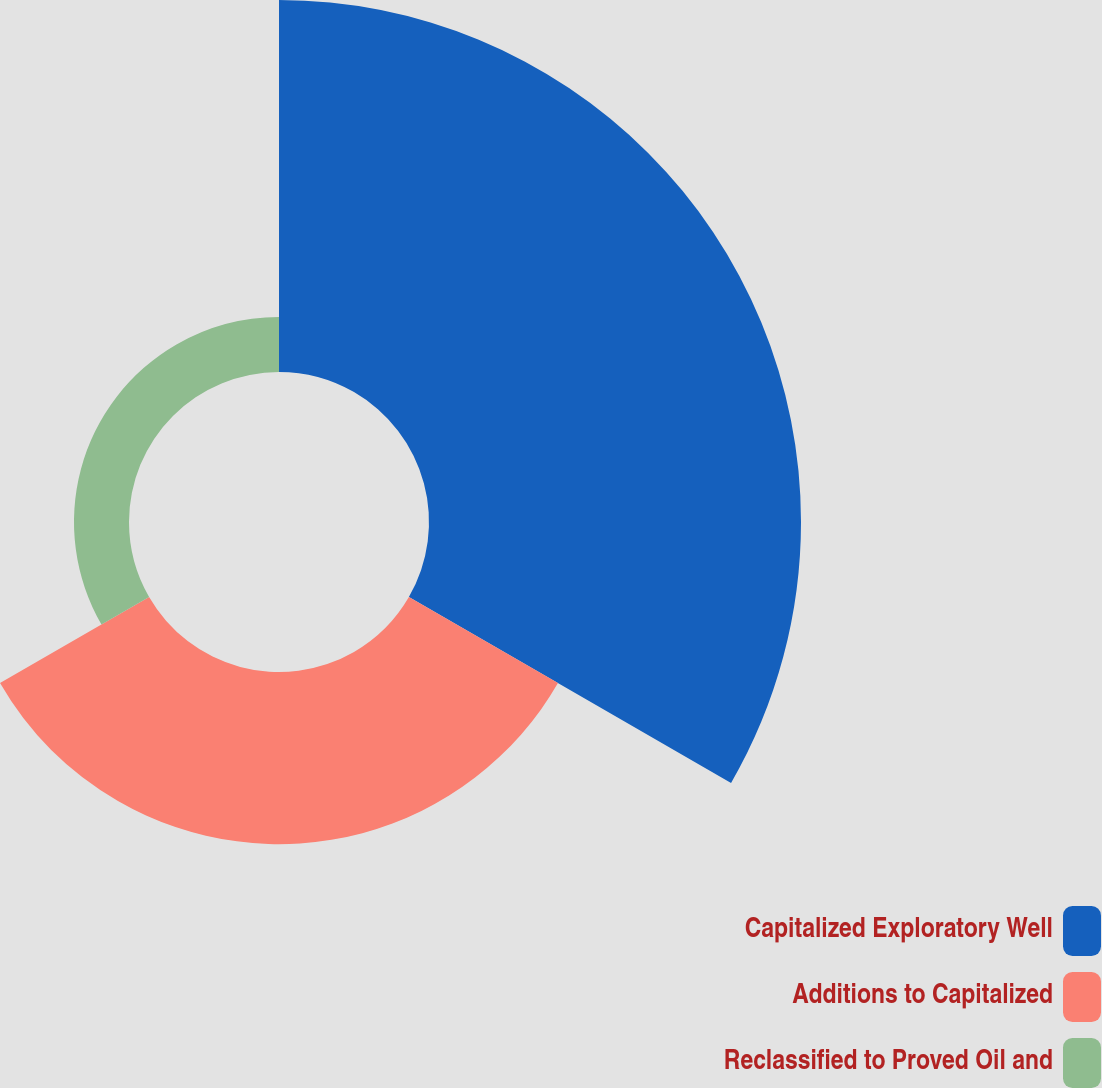<chart> <loc_0><loc_0><loc_500><loc_500><pie_chart><fcel>Capitalized Exploratory Well<fcel>Additions to Capitalized<fcel>Reclassified to Proved Oil and<nl><fcel>62.09%<fcel>28.73%<fcel>9.18%<nl></chart> 